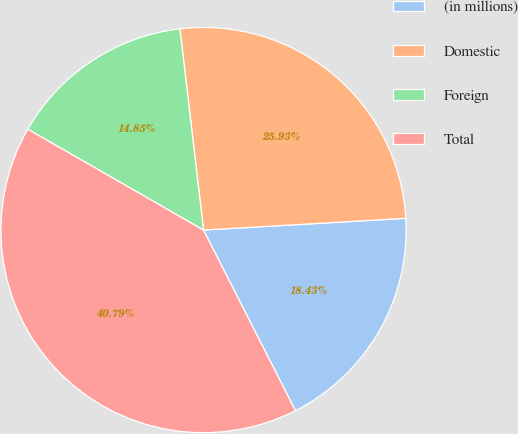Convert chart. <chart><loc_0><loc_0><loc_500><loc_500><pie_chart><fcel>(in millions)<fcel>Domestic<fcel>Foreign<fcel>Total<nl><fcel>18.43%<fcel>25.93%<fcel>14.85%<fcel>40.79%<nl></chart> 